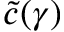Convert formula to latex. <formula><loc_0><loc_0><loc_500><loc_500>\widetilde { c } ( \gamma )</formula> 